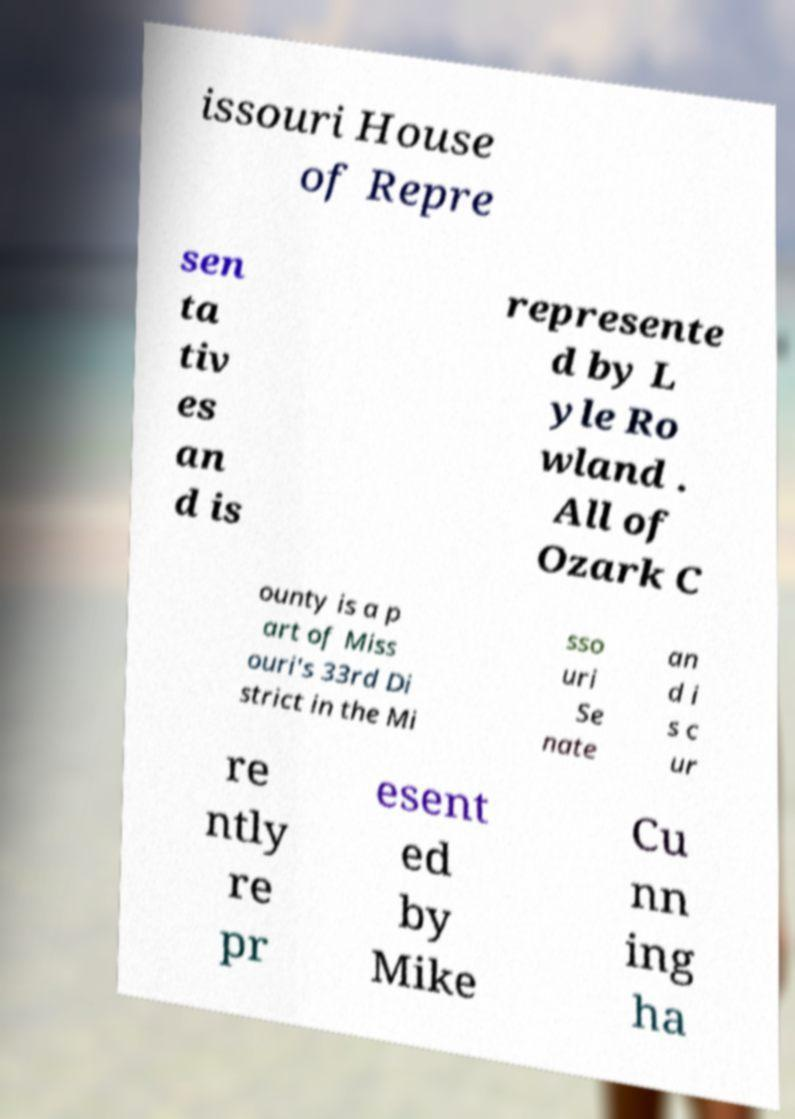Can you read and provide the text displayed in the image?This photo seems to have some interesting text. Can you extract and type it out for me? issouri House of Repre sen ta tiv es an d is represente d by L yle Ro wland . All of Ozark C ounty is a p art of Miss ouri's 33rd Di strict in the Mi sso uri Se nate an d i s c ur re ntly re pr esent ed by Mike Cu nn ing ha 